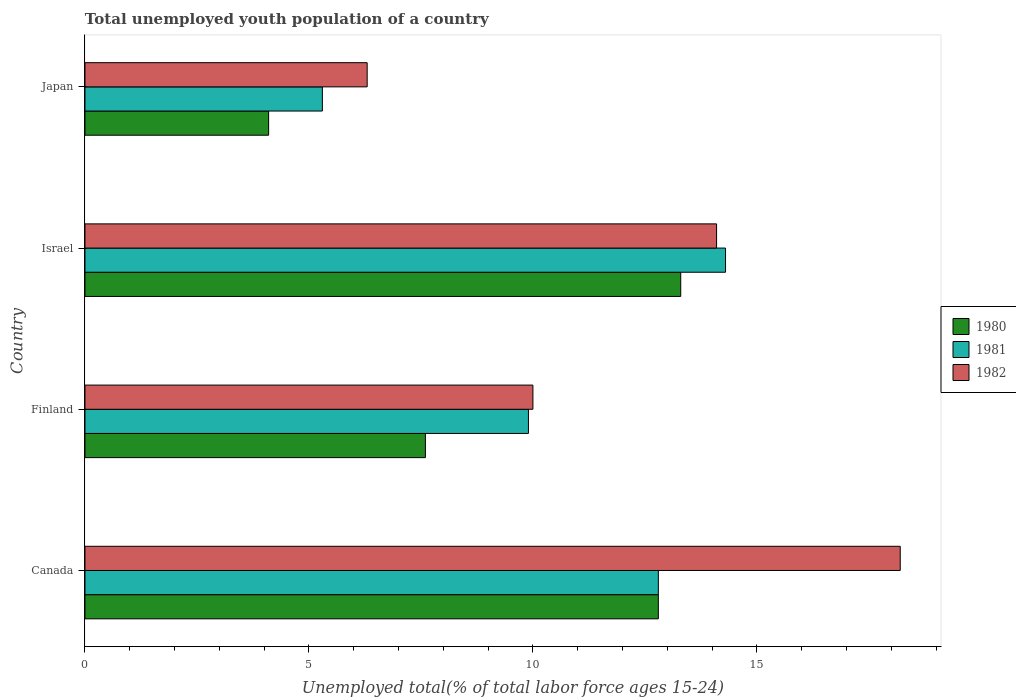How many different coloured bars are there?
Ensure brevity in your answer.  3. How many groups of bars are there?
Offer a very short reply. 4. Are the number of bars per tick equal to the number of legend labels?
Make the answer very short. Yes. Are the number of bars on each tick of the Y-axis equal?
Provide a succinct answer. Yes. In how many cases, is the number of bars for a given country not equal to the number of legend labels?
Ensure brevity in your answer.  0. What is the percentage of total unemployed youth population of a country in 1980 in Finland?
Your response must be concise. 7.6. Across all countries, what is the maximum percentage of total unemployed youth population of a country in 1982?
Give a very brief answer. 18.2. Across all countries, what is the minimum percentage of total unemployed youth population of a country in 1980?
Offer a very short reply. 4.1. In which country was the percentage of total unemployed youth population of a country in 1982 maximum?
Your answer should be compact. Canada. In which country was the percentage of total unemployed youth population of a country in 1982 minimum?
Your answer should be very brief. Japan. What is the total percentage of total unemployed youth population of a country in 1980 in the graph?
Your response must be concise. 37.8. What is the difference between the percentage of total unemployed youth population of a country in 1980 in Canada and that in Japan?
Your response must be concise. 8.7. What is the difference between the percentage of total unemployed youth population of a country in 1981 in Japan and the percentage of total unemployed youth population of a country in 1980 in Canada?
Your answer should be compact. -7.5. What is the average percentage of total unemployed youth population of a country in 1981 per country?
Offer a very short reply. 10.58. What is the difference between the percentage of total unemployed youth population of a country in 1981 and percentage of total unemployed youth population of a country in 1980 in Finland?
Offer a terse response. 2.3. What is the ratio of the percentage of total unemployed youth population of a country in 1981 in Finland to that in Japan?
Your response must be concise. 1.87. What is the difference between the highest and the second highest percentage of total unemployed youth population of a country in 1981?
Your response must be concise. 1.5. What is the difference between the highest and the lowest percentage of total unemployed youth population of a country in 1981?
Your answer should be compact. 9. In how many countries, is the percentage of total unemployed youth population of a country in 1980 greater than the average percentage of total unemployed youth population of a country in 1980 taken over all countries?
Make the answer very short. 2. Is the sum of the percentage of total unemployed youth population of a country in 1980 in Canada and Finland greater than the maximum percentage of total unemployed youth population of a country in 1982 across all countries?
Provide a short and direct response. Yes. What does the 3rd bar from the top in Finland represents?
Your answer should be compact. 1980. What does the 1st bar from the bottom in Israel represents?
Keep it short and to the point. 1980. Are all the bars in the graph horizontal?
Keep it short and to the point. Yes. How many countries are there in the graph?
Offer a very short reply. 4. Does the graph contain any zero values?
Ensure brevity in your answer.  No. Where does the legend appear in the graph?
Provide a succinct answer. Center right. How many legend labels are there?
Ensure brevity in your answer.  3. How are the legend labels stacked?
Keep it short and to the point. Vertical. What is the title of the graph?
Keep it short and to the point. Total unemployed youth population of a country. Does "1998" appear as one of the legend labels in the graph?
Your answer should be compact. No. What is the label or title of the X-axis?
Give a very brief answer. Unemployed total(% of total labor force ages 15-24). What is the Unemployed total(% of total labor force ages 15-24) in 1980 in Canada?
Offer a terse response. 12.8. What is the Unemployed total(% of total labor force ages 15-24) in 1981 in Canada?
Ensure brevity in your answer.  12.8. What is the Unemployed total(% of total labor force ages 15-24) in 1982 in Canada?
Provide a succinct answer. 18.2. What is the Unemployed total(% of total labor force ages 15-24) in 1980 in Finland?
Provide a succinct answer. 7.6. What is the Unemployed total(% of total labor force ages 15-24) of 1981 in Finland?
Offer a terse response. 9.9. What is the Unemployed total(% of total labor force ages 15-24) in 1982 in Finland?
Offer a terse response. 10. What is the Unemployed total(% of total labor force ages 15-24) of 1980 in Israel?
Your response must be concise. 13.3. What is the Unemployed total(% of total labor force ages 15-24) in 1981 in Israel?
Ensure brevity in your answer.  14.3. What is the Unemployed total(% of total labor force ages 15-24) in 1982 in Israel?
Offer a very short reply. 14.1. What is the Unemployed total(% of total labor force ages 15-24) of 1980 in Japan?
Give a very brief answer. 4.1. What is the Unemployed total(% of total labor force ages 15-24) in 1981 in Japan?
Your response must be concise. 5.3. What is the Unemployed total(% of total labor force ages 15-24) in 1982 in Japan?
Offer a terse response. 6.3. Across all countries, what is the maximum Unemployed total(% of total labor force ages 15-24) in 1980?
Make the answer very short. 13.3. Across all countries, what is the maximum Unemployed total(% of total labor force ages 15-24) in 1981?
Offer a very short reply. 14.3. Across all countries, what is the maximum Unemployed total(% of total labor force ages 15-24) in 1982?
Offer a terse response. 18.2. Across all countries, what is the minimum Unemployed total(% of total labor force ages 15-24) of 1980?
Provide a short and direct response. 4.1. Across all countries, what is the minimum Unemployed total(% of total labor force ages 15-24) in 1981?
Offer a terse response. 5.3. Across all countries, what is the minimum Unemployed total(% of total labor force ages 15-24) of 1982?
Provide a short and direct response. 6.3. What is the total Unemployed total(% of total labor force ages 15-24) in 1980 in the graph?
Keep it short and to the point. 37.8. What is the total Unemployed total(% of total labor force ages 15-24) of 1981 in the graph?
Your answer should be very brief. 42.3. What is the total Unemployed total(% of total labor force ages 15-24) of 1982 in the graph?
Keep it short and to the point. 48.6. What is the difference between the Unemployed total(% of total labor force ages 15-24) of 1982 in Canada and that in Finland?
Offer a very short reply. 8.2. What is the difference between the Unemployed total(% of total labor force ages 15-24) of 1981 in Canada and that in Israel?
Provide a succinct answer. -1.5. What is the difference between the Unemployed total(% of total labor force ages 15-24) in 1981 in Canada and that in Japan?
Offer a terse response. 7.5. What is the difference between the Unemployed total(% of total labor force ages 15-24) of 1980 in Finland and that in Israel?
Offer a very short reply. -5.7. What is the difference between the Unemployed total(% of total labor force ages 15-24) of 1981 in Finland and that in Israel?
Your response must be concise. -4.4. What is the difference between the Unemployed total(% of total labor force ages 15-24) of 1980 in Israel and that in Japan?
Offer a terse response. 9.2. What is the difference between the Unemployed total(% of total labor force ages 15-24) of 1980 in Canada and the Unemployed total(% of total labor force ages 15-24) of 1981 in Finland?
Your response must be concise. 2.9. What is the difference between the Unemployed total(% of total labor force ages 15-24) in 1980 in Canada and the Unemployed total(% of total labor force ages 15-24) in 1982 in Finland?
Ensure brevity in your answer.  2.8. What is the difference between the Unemployed total(% of total labor force ages 15-24) in 1981 in Canada and the Unemployed total(% of total labor force ages 15-24) in 1982 in Israel?
Offer a very short reply. -1.3. What is the difference between the Unemployed total(% of total labor force ages 15-24) in 1981 in Canada and the Unemployed total(% of total labor force ages 15-24) in 1982 in Japan?
Your response must be concise. 6.5. What is the difference between the Unemployed total(% of total labor force ages 15-24) of 1980 in Finland and the Unemployed total(% of total labor force ages 15-24) of 1981 in Israel?
Provide a succinct answer. -6.7. What is the difference between the Unemployed total(% of total labor force ages 15-24) of 1980 in Finland and the Unemployed total(% of total labor force ages 15-24) of 1981 in Japan?
Provide a succinct answer. 2.3. What is the difference between the Unemployed total(% of total labor force ages 15-24) of 1981 in Finland and the Unemployed total(% of total labor force ages 15-24) of 1982 in Japan?
Your answer should be compact. 3.6. What is the average Unemployed total(% of total labor force ages 15-24) of 1980 per country?
Keep it short and to the point. 9.45. What is the average Unemployed total(% of total labor force ages 15-24) in 1981 per country?
Your answer should be very brief. 10.57. What is the average Unemployed total(% of total labor force ages 15-24) in 1982 per country?
Give a very brief answer. 12.15. What is the difference between the Unemployed total(% of total labor force ages 15-24) in 1980 and Unemployed total(% of total labor force ages 15-24) in 1981 in Canada?
Your answer should be compact. 0. What is the difference between the Unemployed total(% of total labor force ages 15-24) of 1981 and Unemployed total(% of total labor force ages 15-24) of 1982 in Canada?
Your answer should be compact. -5.4. What is the difference between the Unemployed total(% of total labor force ages 15-24) in 1980 and Unemployed total(% of total labor force ages 15-24) in 1982 in Finland?
Ensure brevity in your answer.  -2.4. What is the difference between the Unemployed total(% of total labor force ages 15-24) of 1980 and Unemployed total(% of total labor force ages 15-24) of 1982 in Israel?
Offer a very short reply. -0.8. What is the difference between the Unemployed total(% of total labor force ages 15-24) of 1981 and Unemployed total(% of total labor force ages 15-24) of 1982 in Israel?
Give a very brief answer. 0.2. What is the difference between the Unemployed total(% of total labor force ages 15-24) in 1980 and Unemployed total(% of total labor force ages 15-24) in 1982 in Japan?
Your answer should be compact. -2.2. What is the difference between the Unemployed total(% of total labor force ages 15-24) of 1981 and Unemployed total(% of total labor force ages 15-24) of 1982 in Japan?
Provide a short and direct response. -1. What is the ratio of the Unemployed total(% of total labor force ages 15-24) of 1980 in Canada to that in Finland?
Make the answer very short. 1.68. What is the ratio of the Unemployed total(% of total labor force ages 15-24) in 1981 in Canada to that in Finland?
Make the answer very short. 1.29. What is the ratio of the Unemployed total(% of total labor force ages 15-24) of 1982 in Canada to that in Finland?
Provide a short and direct response. 1.82. What is the ratio of the Unemployed total(% of total labor force ages 15-24) of 1980 in Canada to that in Israel?
Offer a very short reply. 0.96. What is the ratio of the Unemployed total(% of total labor force ages 15-24) of 1981 in Canada to that in Israel?
Ensure brevity in your answer.  0.9. What is the ratio of the Unemployed total(% of total labor force ages 15-24) in 1982 in Canada to that in Israel?
Offer a terse response. 1.29. What is the ratio of the Unemployed total(% of total labor force ages 15-24) of 1980 in Canada to that in Japan?
Ensure brevity in your answer.  3.12. What is the ratio of the Unemployed total(% of total labor force ages 15-24) in 1981 in Canada to that in Japan?
Give a very brief answer. 2.42. What is the ratio of the Unemployed total(% of total labor force ages 15-24) in 1982 in Canada to that in Japan?
Provide a succinct answer. 2.89. What is the ratio of the Unemployed total(% of total labor force ages 15-24) in 1981 in Finland to that in Israel?
Your answer should be very brief. 0.69. What is the ratio of the Unemployed total(% of total labor force ages 15-24) of 1982 in Finland to that in Israel?
Provide a succinct answer. 0.71. What is the ratio of the Unemployed total(% of total labor force ages 15-24) in 1980 in Finland to that in Japan?
Offer a very short reply. 1.85. What is the ratio of the Unemployed total(% of total labor force ages 15-24) in 1981 in Finland to that in Japan?
Keep it short and to the point. 1.87. What is the ratio of the Unemployed total(% of total labor force ages 15-24) of 1982 in Finland to that in Japan?
Your answer should be very brief. 1.59. What is the ratio of the Unemployed total(% of total labor force ages 15-24) of 1980 in Israel to that in Japan?
Make the answer very short. 3.24. What is the ratio of the Unemployed total(% of total labor force ages 15-24) in 1981 in Israel to that in Japan?
Offer a very short reply. 2.7. What is the ratio of the Unemployed total(% of total labor force ages 15-24) in 1982 in Israel to that in Japan?
Make the answer very short. 2.24. What is the difference between the highest and the second highest Unemployed total(% of total labor force ages 15-24) in 1981?
Ensure brevity in your answer.  1.5. 